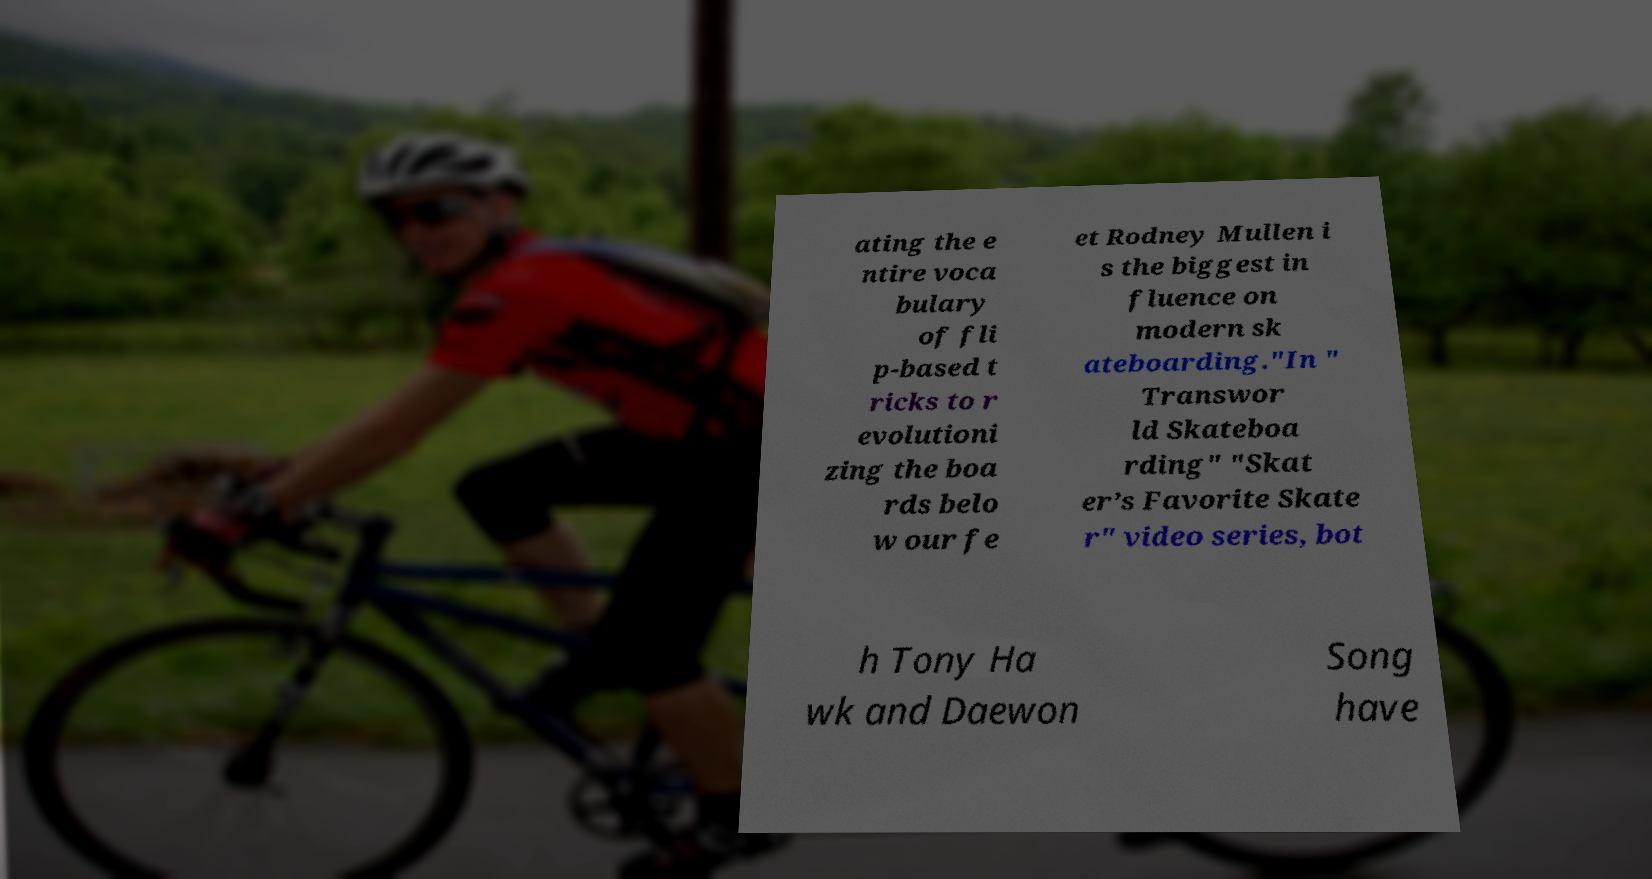Can you accurately transcribe the text from the provided image for me? ating the e ntire voca bulary of fli p-based t ricks to r evolutioni zing the boa rds belo w our fe et Rodney Mullen i s the biggest in fluence on modern sk ateboarding."In " Transwor ld Skateboa rding" "Skat er’s Favorite Skate r" video series, bot h Tony Ha wk and Daewon Song have 